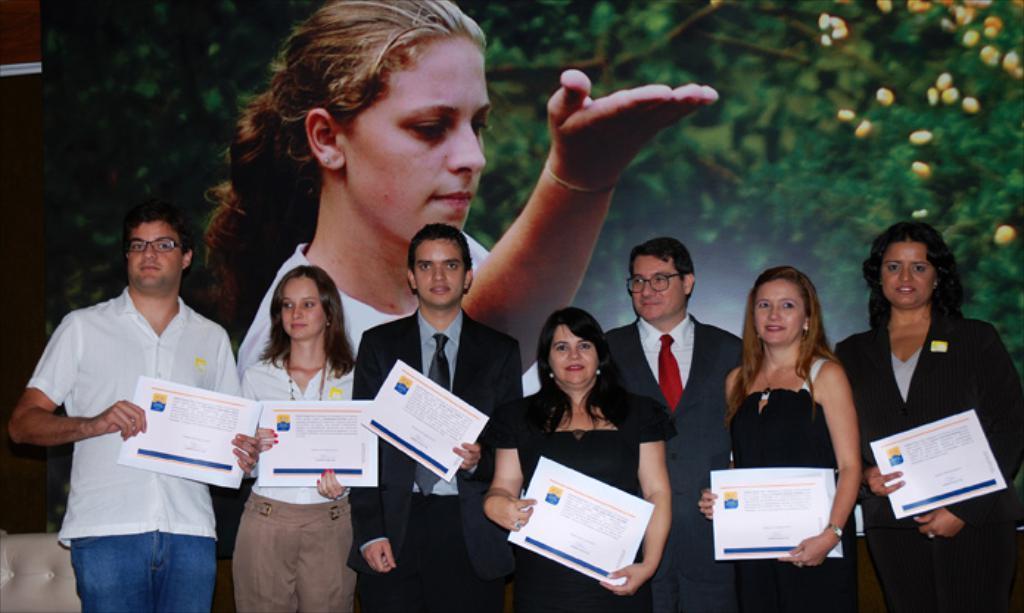How would you summarize this image in a sentence or two? Here I can see few people holding some cards in their hands, standing and giving pose for the picture. In the bottom left there is a chair. In the background there is a screen on which I can see a woman and some trees. 